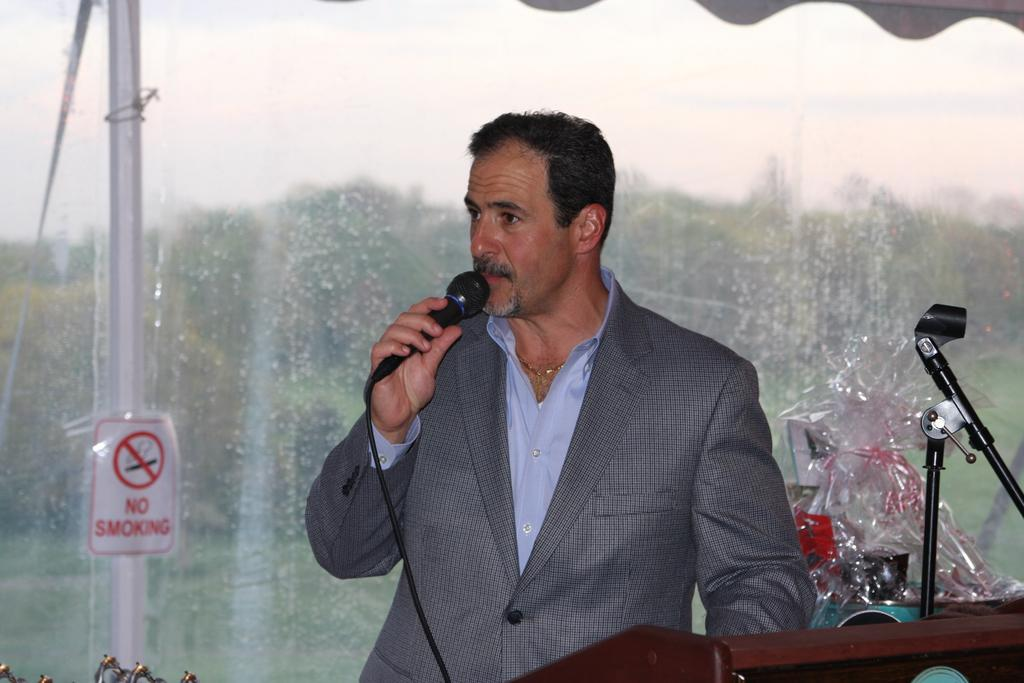What is the person in the image wearing? There is a person wearing a suit in the image. What is the person in the image doing? The person is standing and speaking in front of a microphone. Can you tell me how many kittens are sitting on the person's shoulders in the image? There are no kittens present in the image. What invention is the person using to amplify their voice in the image? The person is speaking in front of a microphone, but there is no specific invention mentioned in the facts provided. 